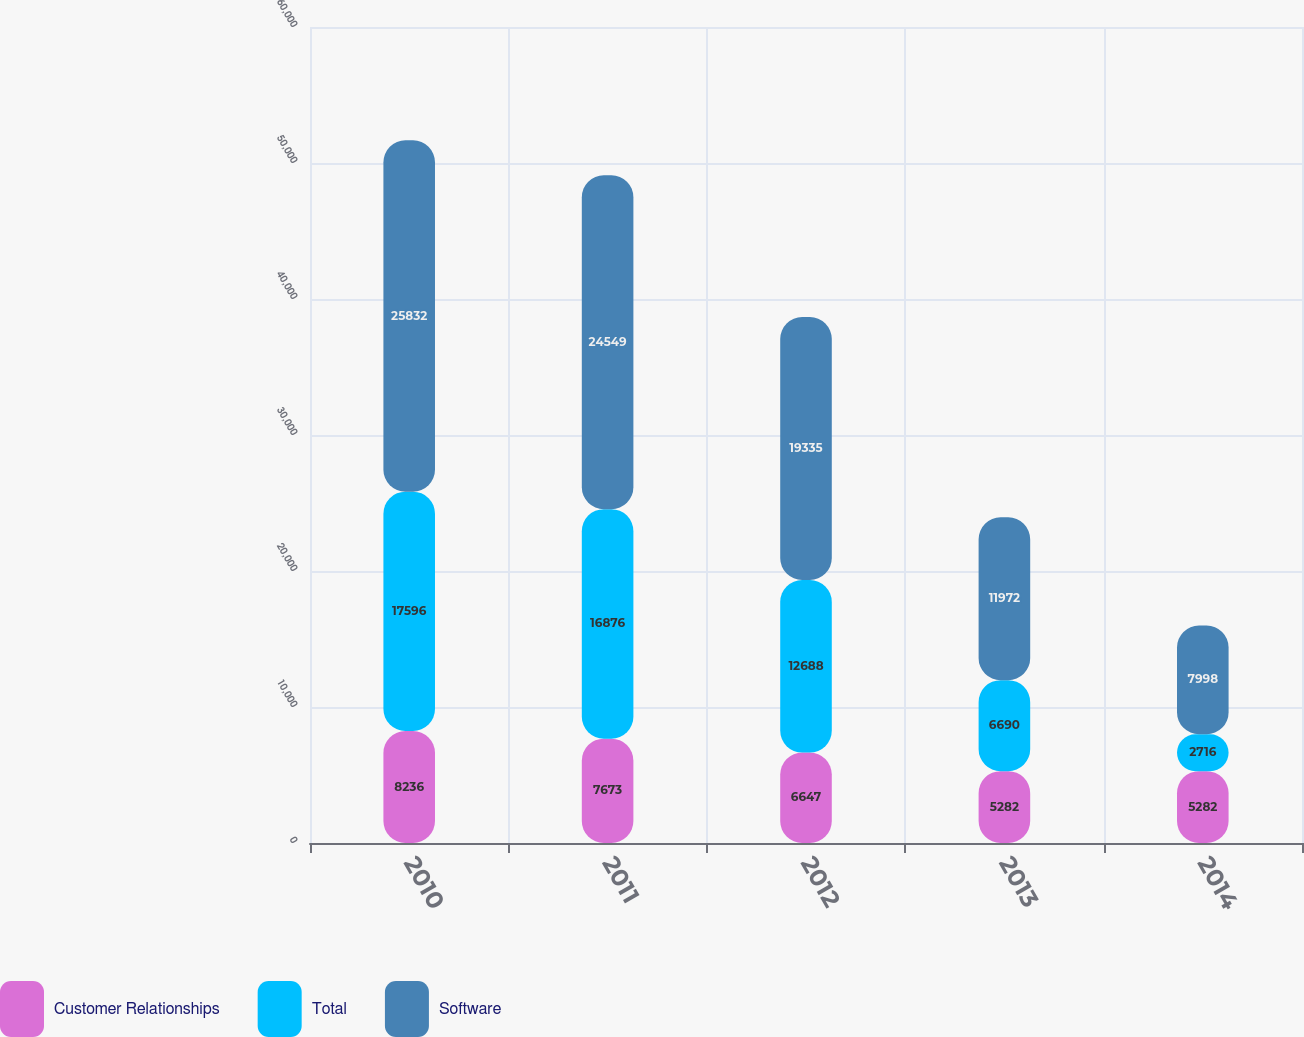Convert chart. <chart><loc_0><loc_0><loc_500><loc_500><stacked_bar_chart><ecel><fcel>2010<fcel>2011<fcel>2012<fcel>2013<fcel>2014<nl><fcel>Customer Relationships<fcel>8236<fcel>7673<fcel>6647<fcel>5282<fcel>5282<nl><fcel>Total<fcel>17596<fcel>16876<fcel>12688<fcel>6690<fcel>2716<nl><fcel>Software<fcel>25832<fcel>24549<fcel>19335<fcel>11972<fcel>7998<nl></chart> 